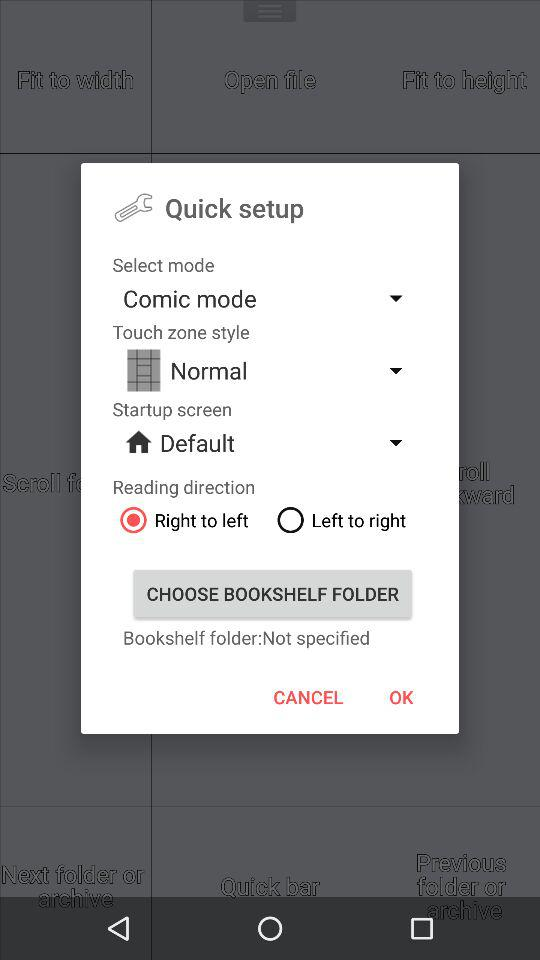Which mode is selected? The selected mode is "Comic mode". 